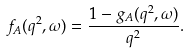<formula> <loc_0><loc_0><loc_500><loc_500>f _ { A } ( q ^ { 2 } , \omega ) = \frac { 1 - g _ { A } ( q ^ { 2 } , \omega ) } { q ^ { 2 } } .</formula> 